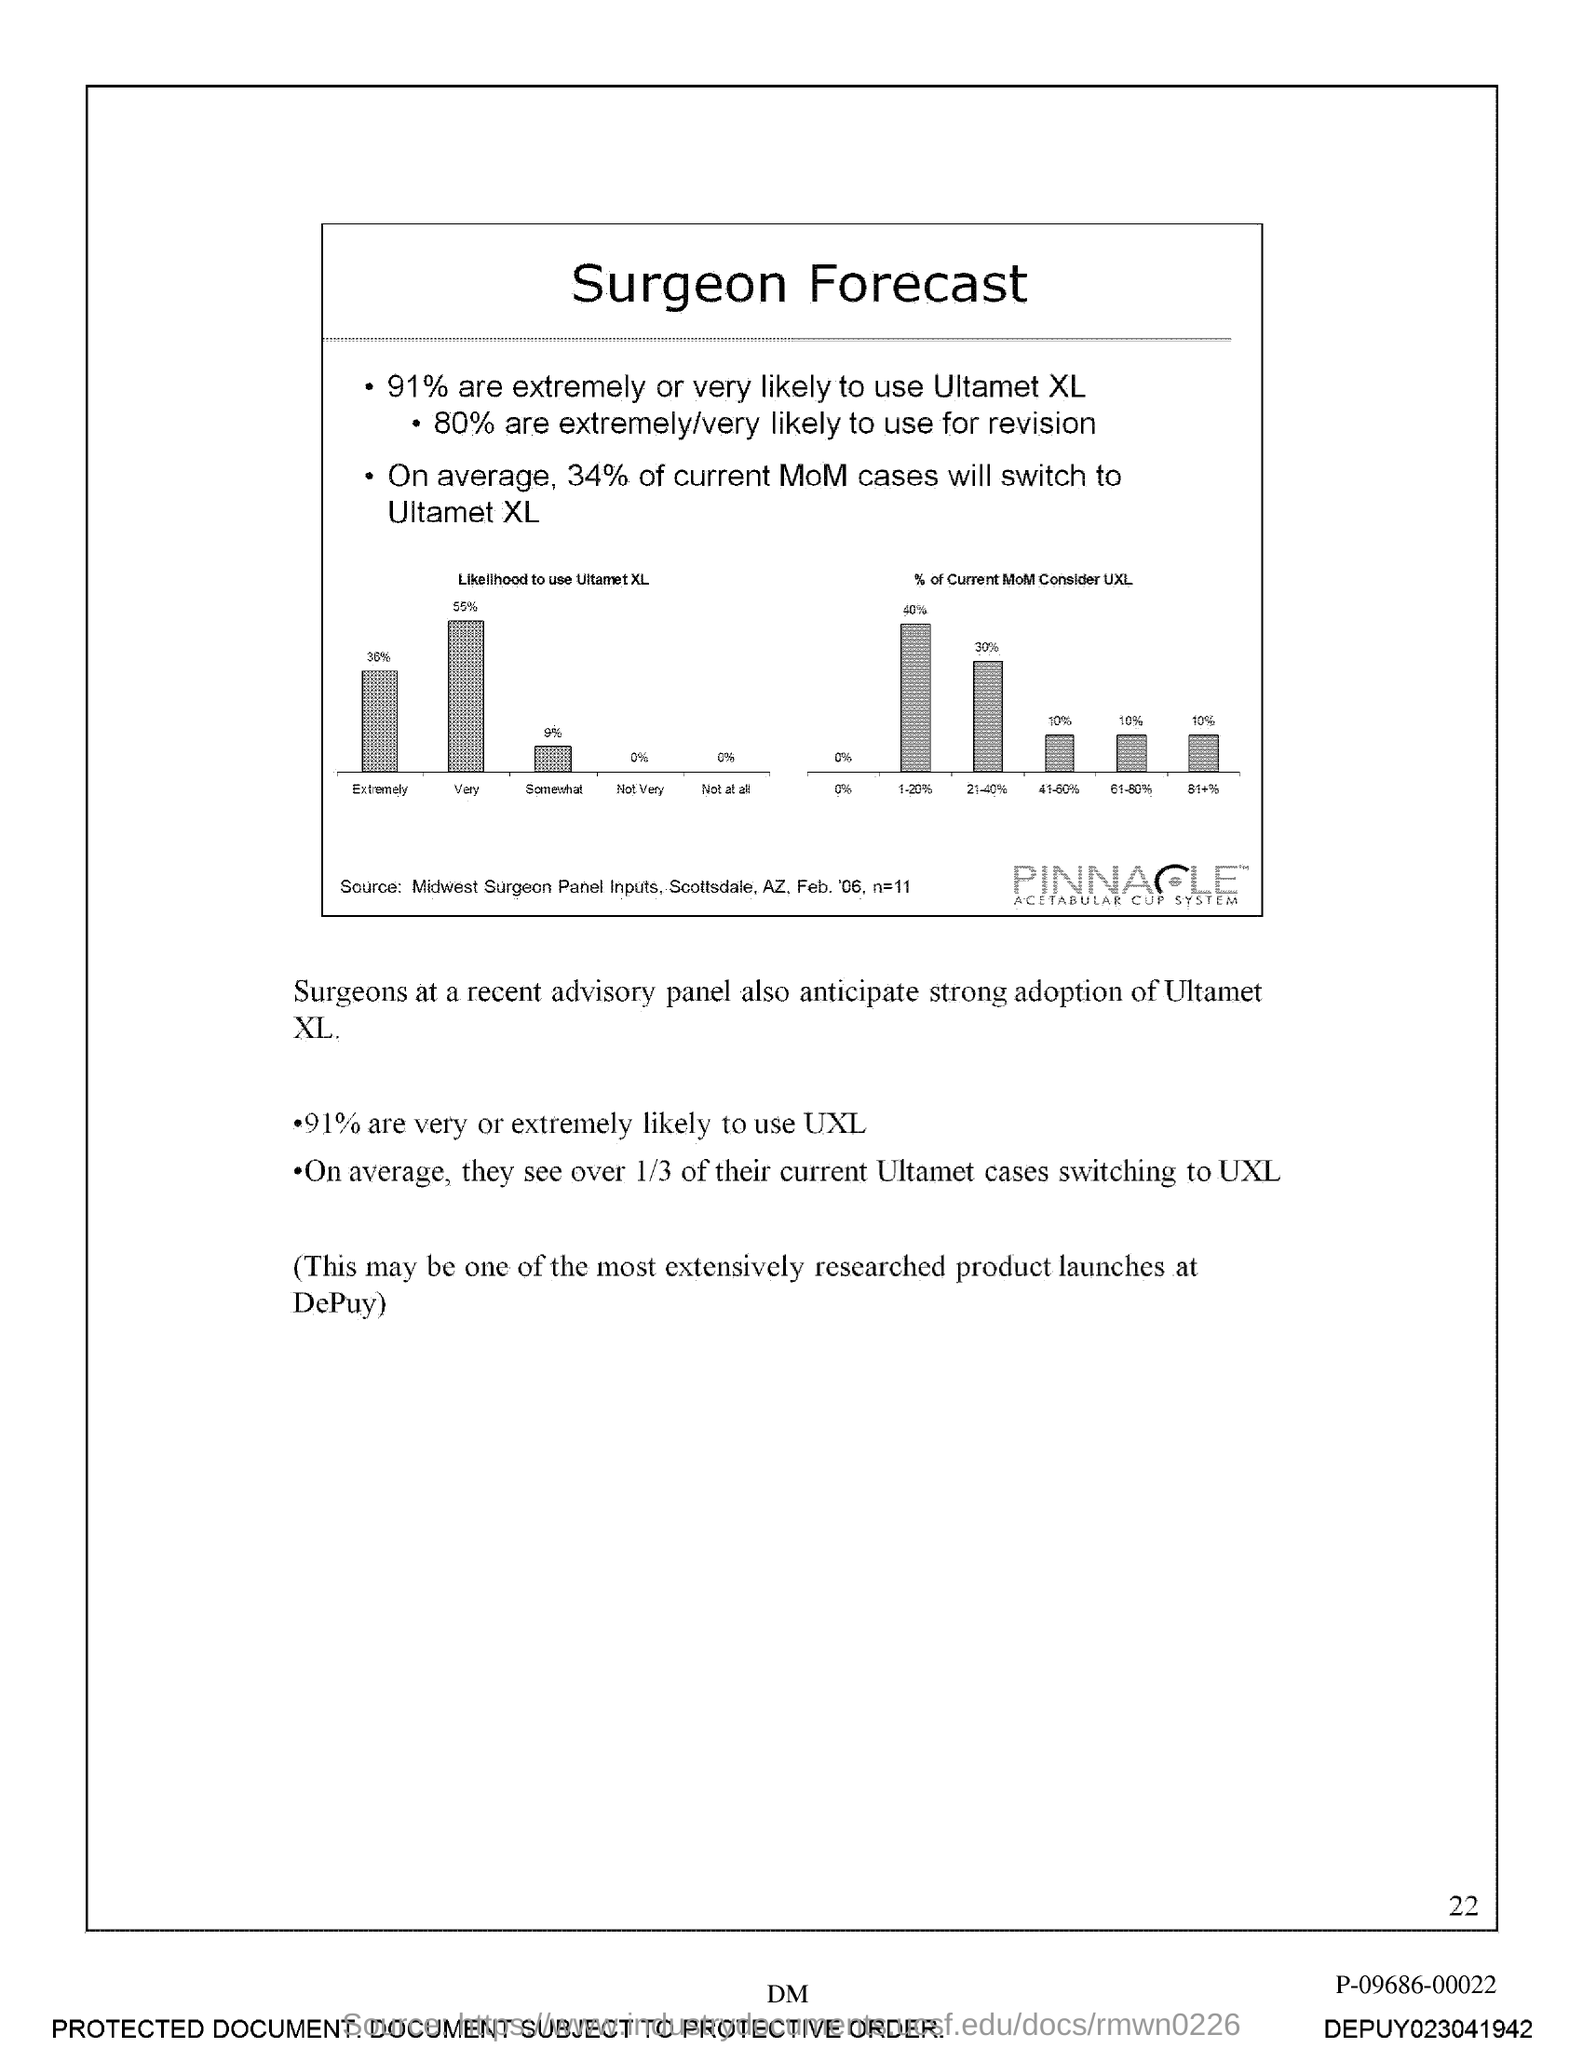What is the title of the document?
Your answer should be compact. Surgeon Forecast. What is the Page Number?
Provide a short and direct response. 22. 